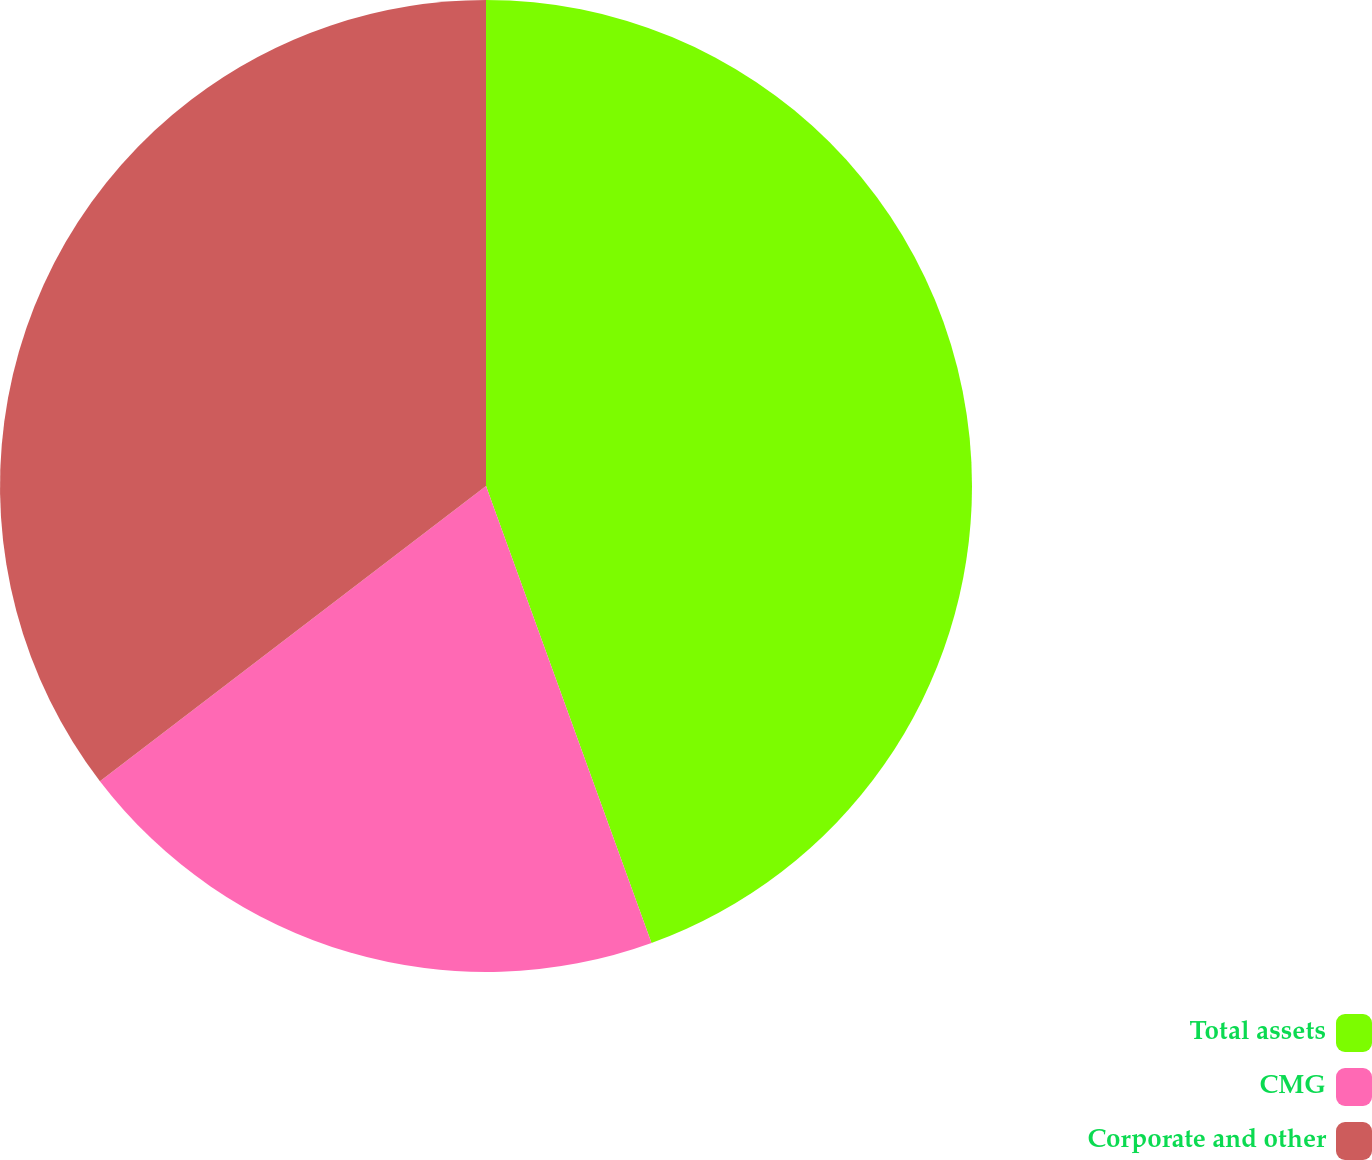Convert chart to OTSL. <chart><loc_0><loc_0><loc_500><loc_500><pie_chart><fcel>Total assets<fcel>CMG<fcel>Corporate and other<nl><fcel>44.47%<fcel>20.14%<fcel>35.39%<nl></chart> 